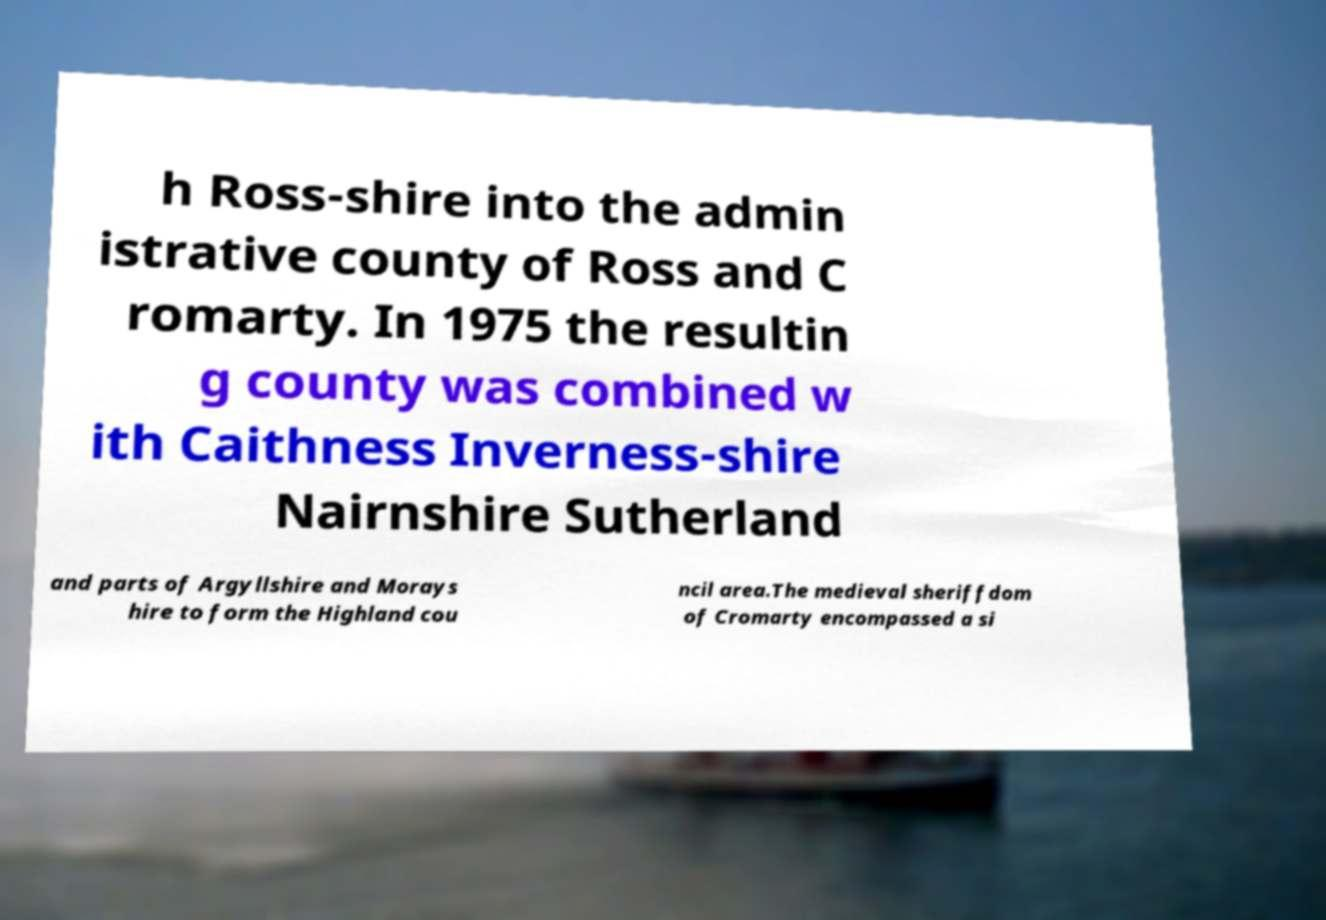Could you extract and type out the text from this image? h Ross-shire into the admin istrative county of Ross and C romarty. In 1975 the resultin g county was combined w ith Caithness Inverness-shire Nairnshire Sutherland and parts of Argyllshire and Morays hire to form the Highland cou ncil area.The medieval sheriffdom of Cromarty encompassed a si 